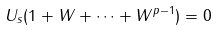<formula> <loc_0><loc_0><loc_500><loc_500>U _ { s } ( 1 + W + \cdots + W ^ { p - 1 } ) = 0</formula> 